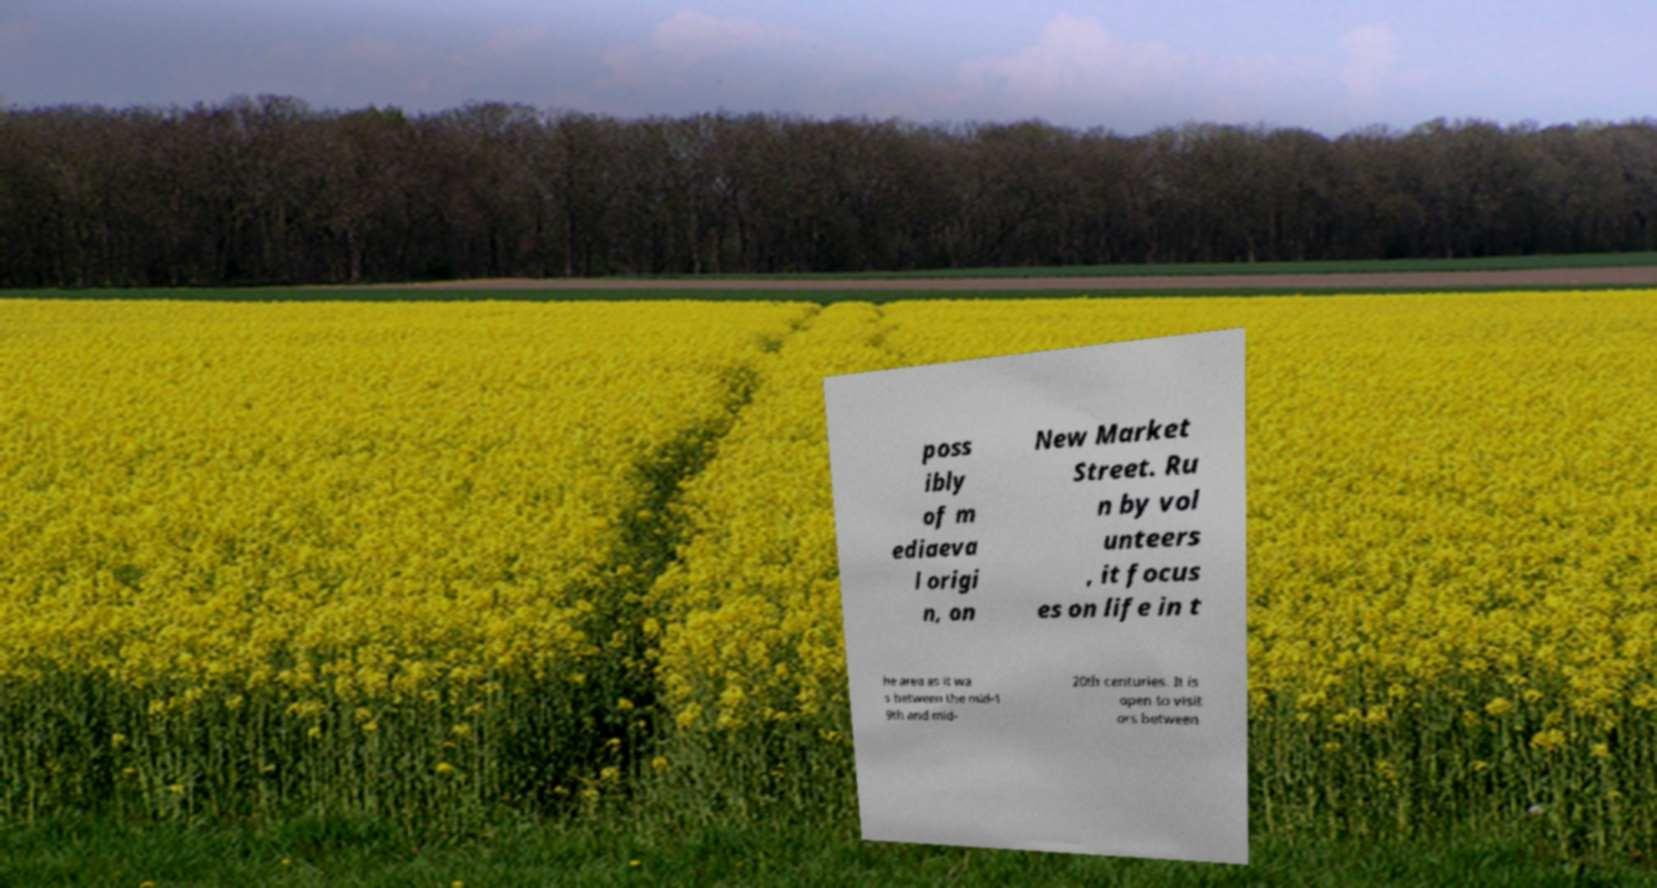Can you read and provide the text displayed in the image?This photo seems to have some interesting text. Can you extract and type it out for me? poss ibly of m ediaeva l origi n, on New Market Street. Ru n by vol unteers , it focus es on life in t he area as it wa s between the mid-1 9th and mid- 20th centuries. It is open to visit ors between 